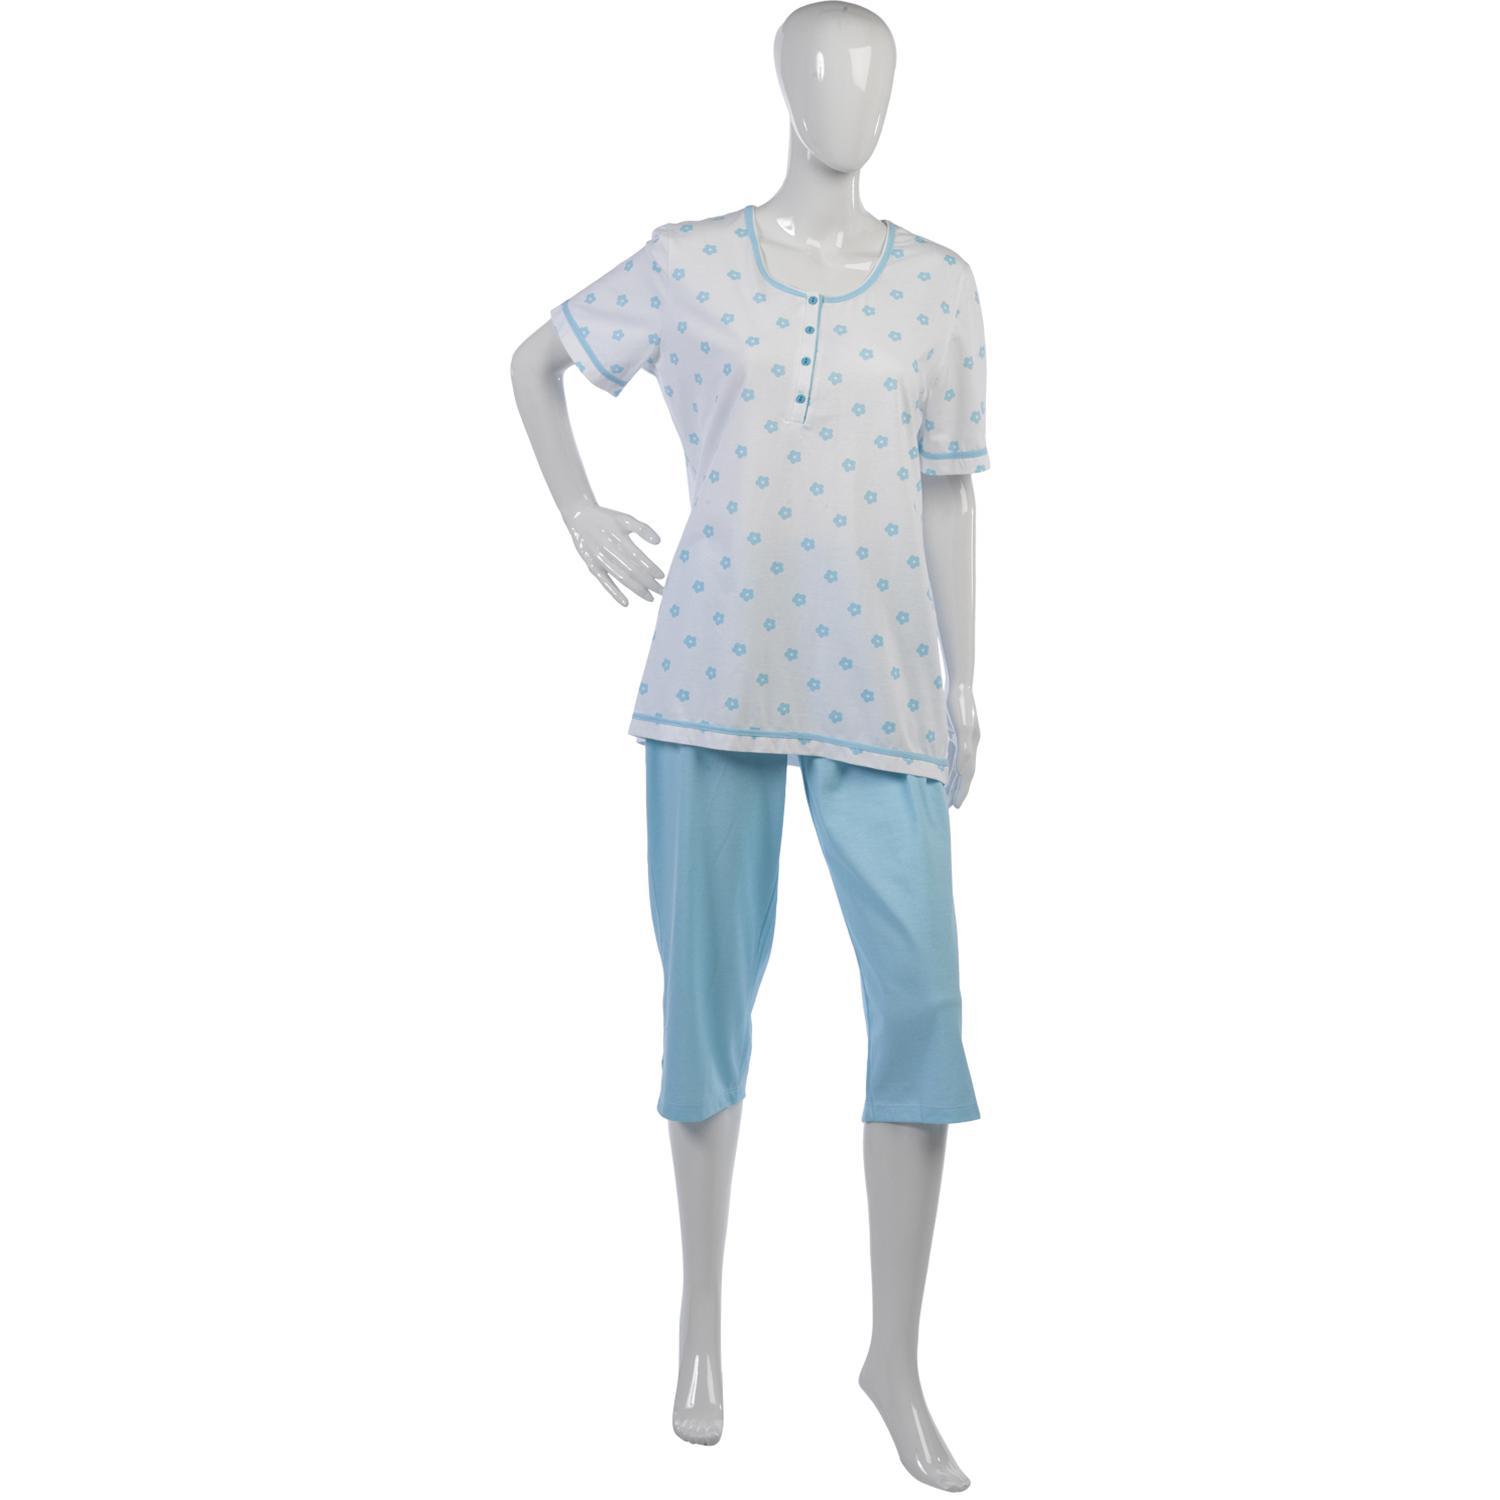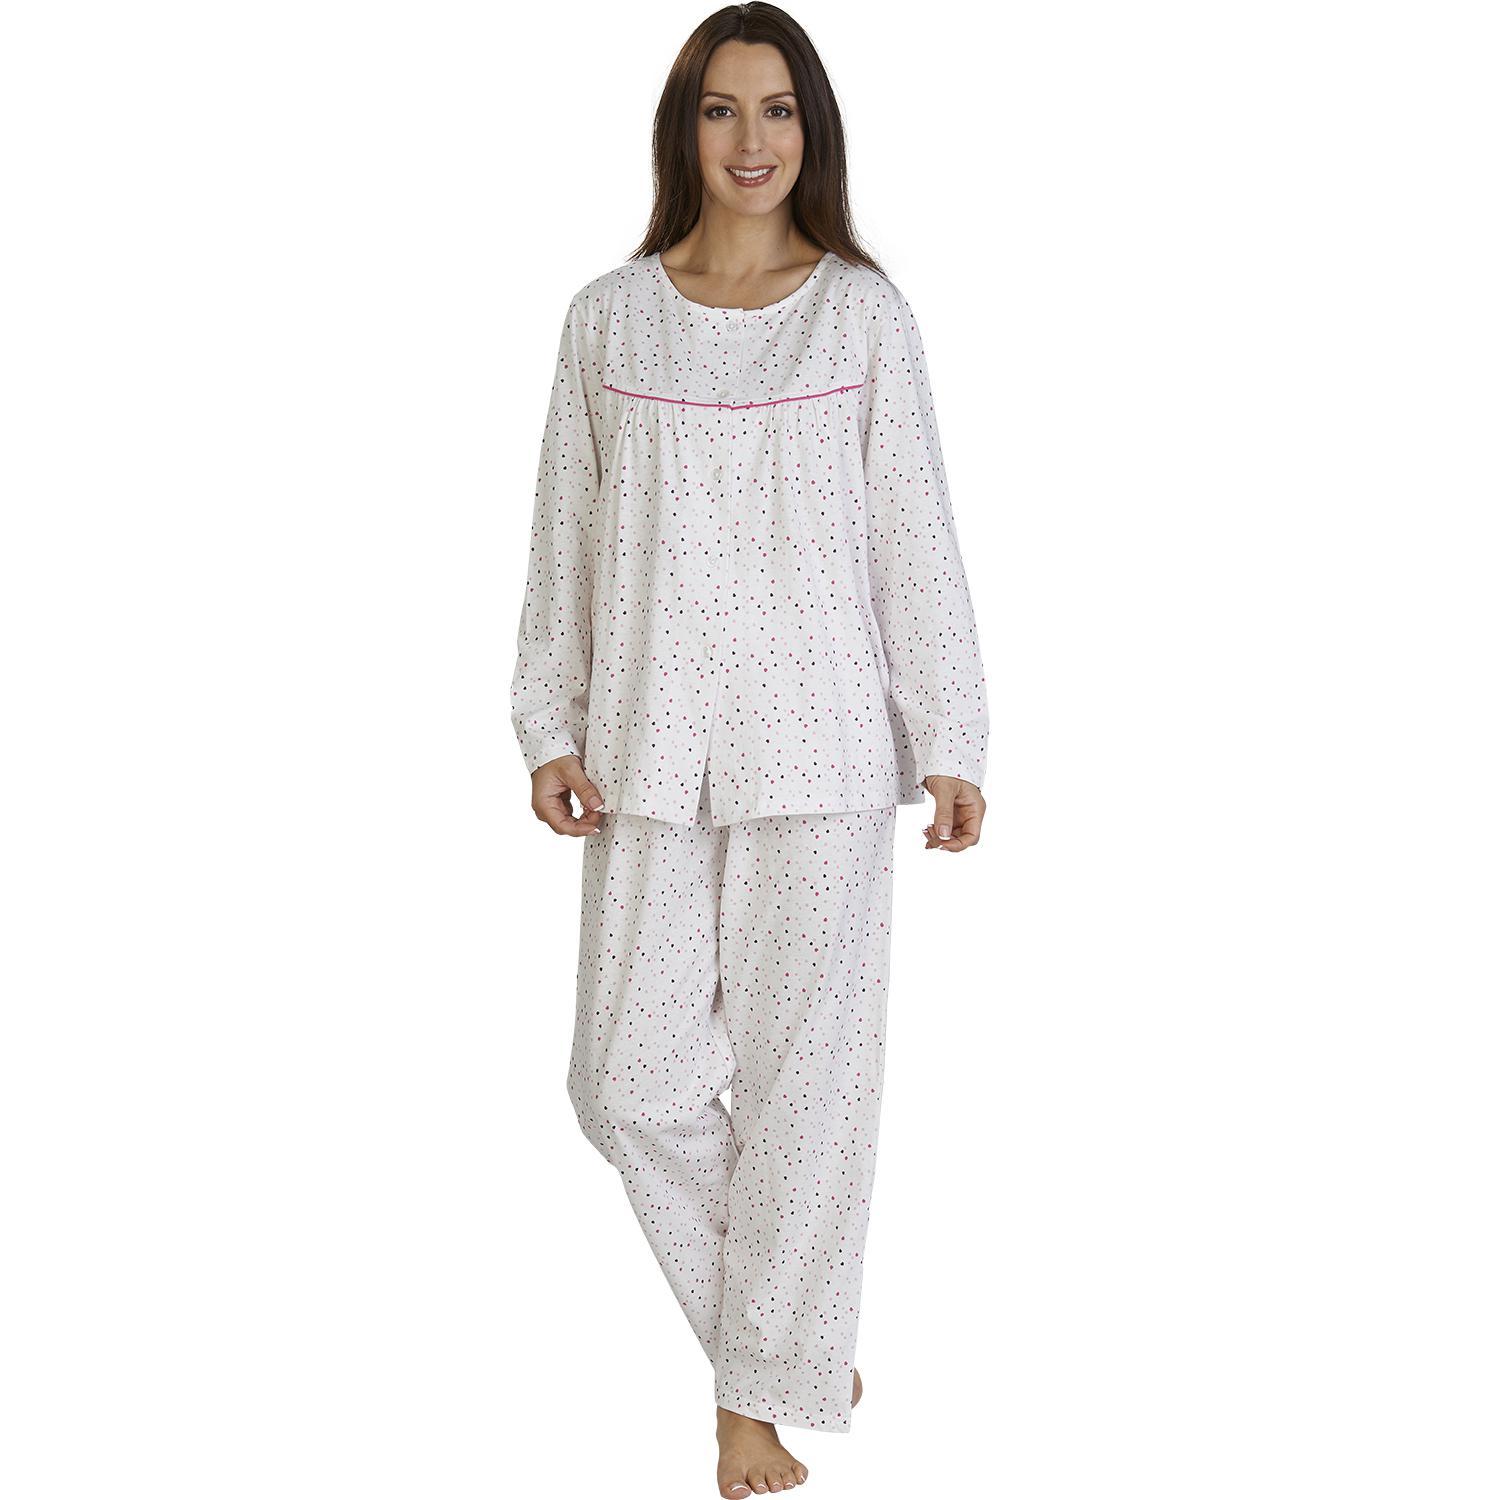The first image is the image on the left, the second image is the image on the right. For the images displayed, is the sentence "At least one pair of pajamas are polka-dotted." factually correct? Answer yes or no. Yes. The first image is the image on the left, the second image is the image on the right. Examine the images to the left and right. Is the description "The image on the left has a mannequin wearing sleep attire." accurate? Answer yes or no. Yes. 